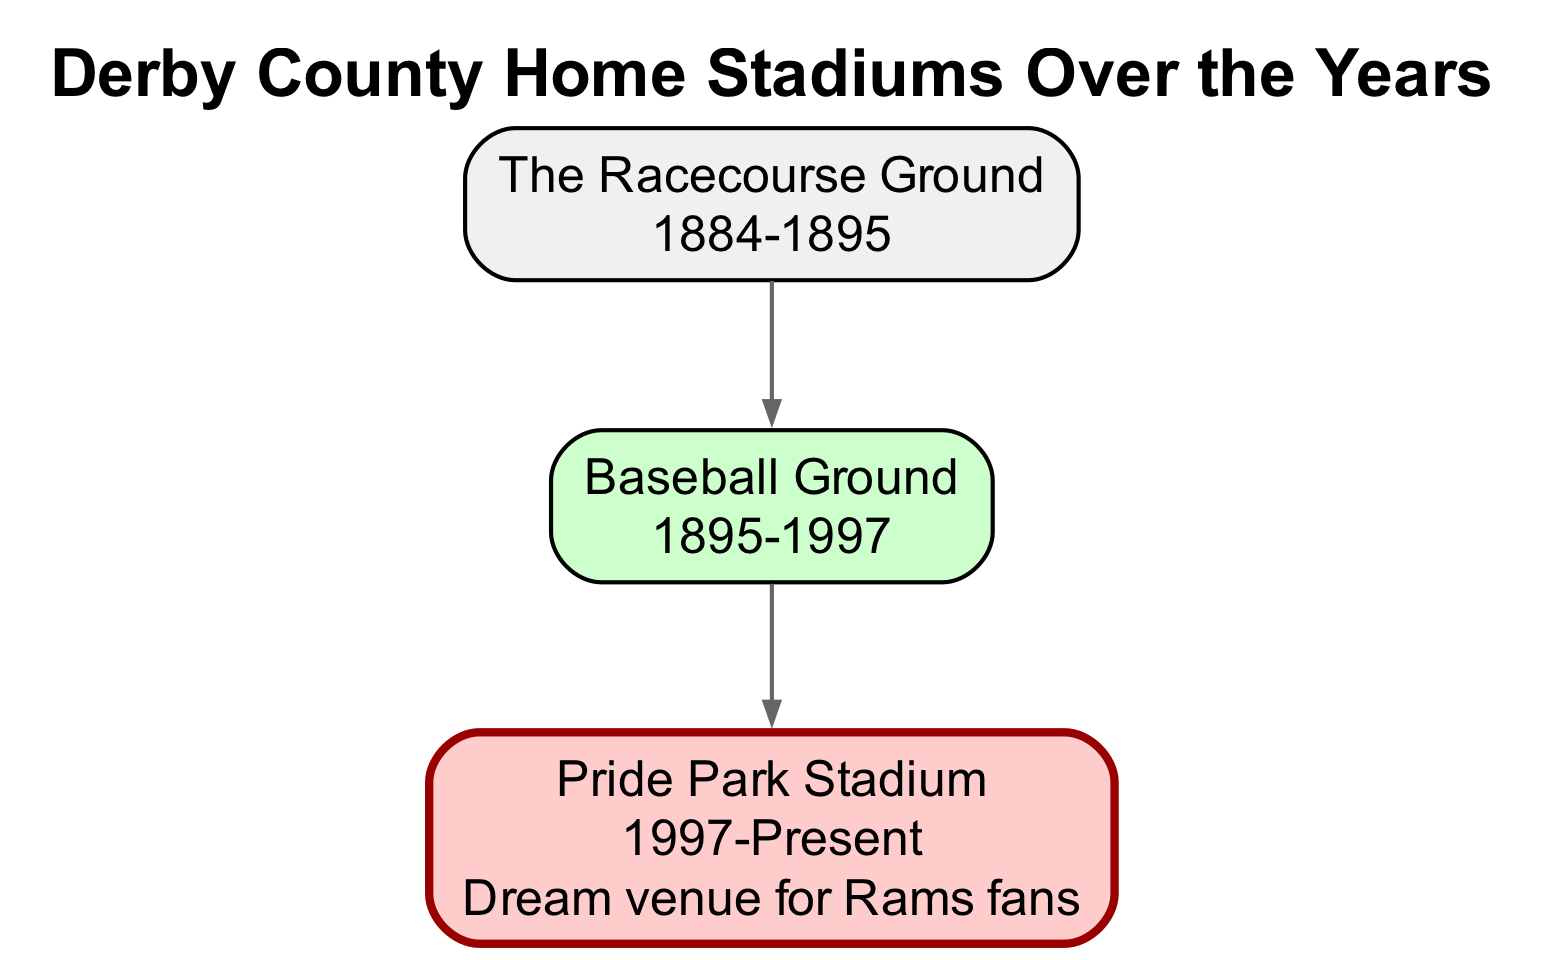What was Derby County's first home stadium? The diagram indicates that Derby County's first home stadium was The Racecourse Ground, with the dates of operation spanning from 1884 to 1895.
Answer: The Racecourse Ground What year did Derby County move to Pride Park Stadium? According to the diagram, Derby County moved to Pride Park Stadium in 1997, as it reflects the years of operation for each stadium.
Answer: 1997 How many home stadiums did Derby County have before Pride Park Stadium? The diagram shows that there are two stadiums listed before Pride Park Stadium: The Racecourse Ground and Baseball Ground. Therefore, the count is two.
Answer: 2 Which home stadium is described as the "Dream venue for Rams fans"? The diagram notes that Pride Park Stadium is referred to as the "Dream venue for Rams fans," showing an added layer of information regarding fan sentiment associated with the stadium.
Answer: Pride Park Stadium What were the years of operation for the Baseball Ground? The diagram lists the Baseball Ground's years of operation from 1895 to 1997.
Answer: 1895-1997 Which stadium succeeded the Baseball Ground? The diagram clearly points out that Pride Park Stadium is the direct successor to the Baseball Ground, indicating the progression of stadium venues for Derby County.
Answer: Pride Park Stadium How many total home stadiums has Derby County had? By examining the diagram, it is clear that Derby County has had three distinct home stadiums: The Racecourse Ground, Baseball Ground, and Pride Park Stadium, leading to a total count of three.
Answer: 3 What is the relationship between The Racecourse Ground and Baseball Ground in the diagram? The diagram illustrates a parent-child relationship where The Racecourse Ground is the parent node and the Baseball Ground is a child node, indicating that after using The Racecourse Ground, Derby County moved to the Baseball Ground.
Answer: The Racecourse Ground is the parent of Baseball Ground What is the final home stadium listed in the diagram? The diagram showcases Pride Park Stadium as the final home stadium and indicates its current status, making it evident that it is still in use now.
Answer: Pride Park Stadium 